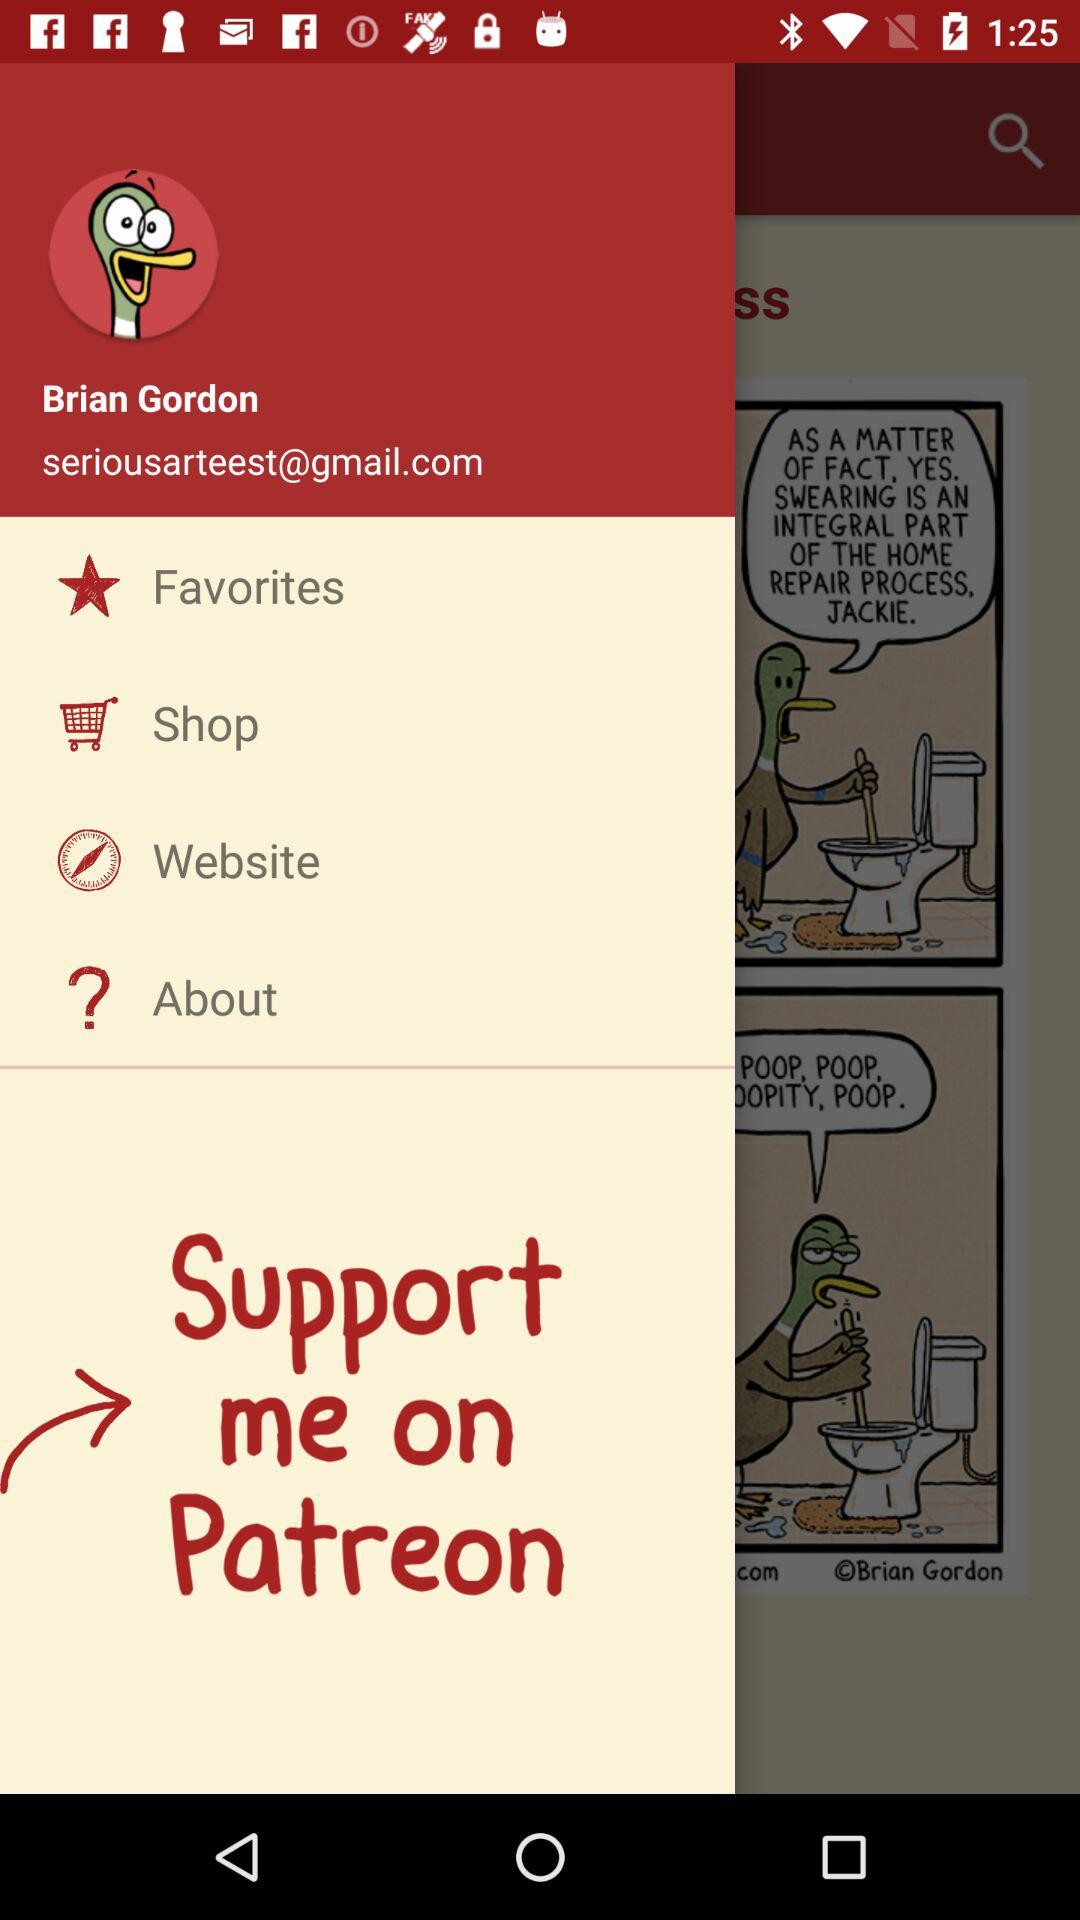What is the user name? The user name is Brian Gordon. 